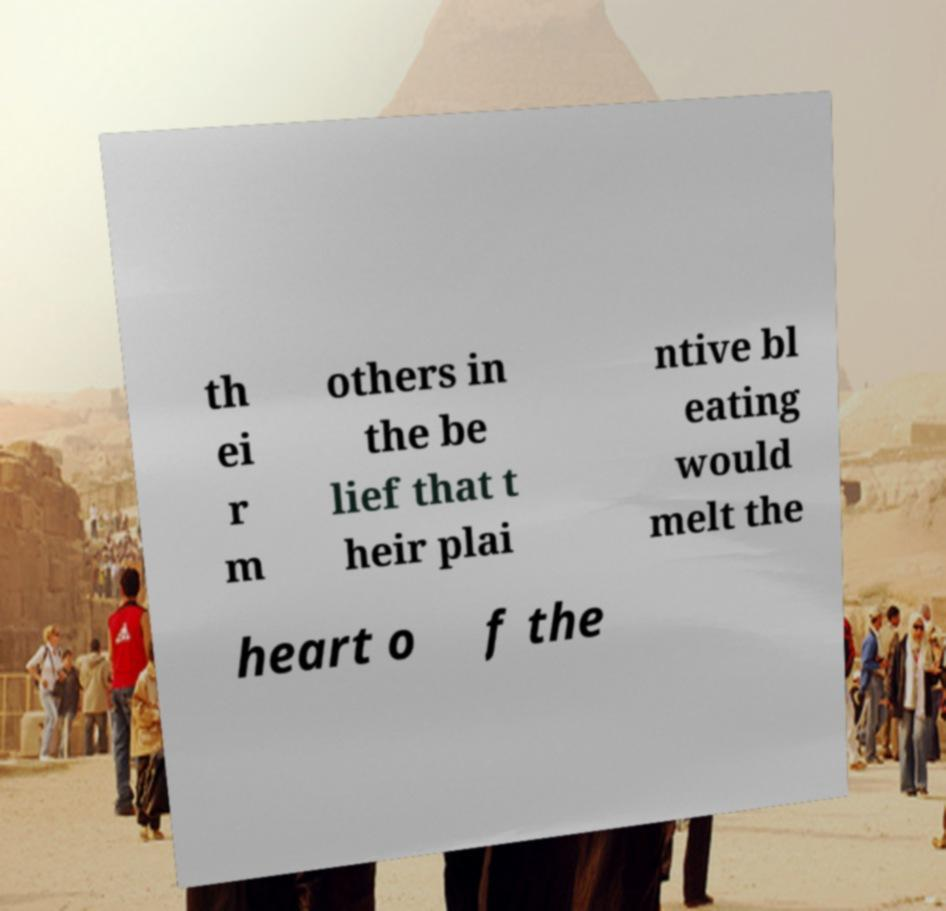Please identify and transcribe the text found in this image. th ei r m others in the be lief that t heir plai ntive bl eating would melt the heart o f the 